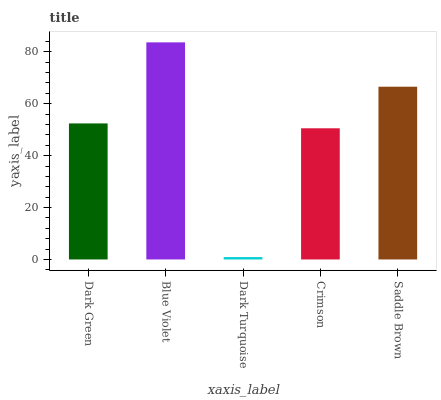Is Dark Turquoise the minimum?
Answer yes or no. Yes. Is Blue Violet the maximum?
Answer yes or no. Yes. Is Blue Violet the minimum?
Answer yes or no. No. Is Dark Turquoise the maximum?
Answer yes or no. No. Is Blue Violet greater than Dark Turquoise?
Answer yes or no. Yes. Is Dark Turquoise less than Blue Violet?
Answer yes or no. Yes. Is Dark Turquoise greater than Blue Violet?
Answer yes or no. No. Is Blue Violet less than Dark Turquoise?
Answer yes or no. No. Is Dark Green the high median?
Answer yes or no. Yes. Is Dark Green the low median?
Answer yes or no. Yes. Is Blue Violet the high median?
Answer yes or no. No. Is Blue Violet the low median?
Answer yes or no. No. 